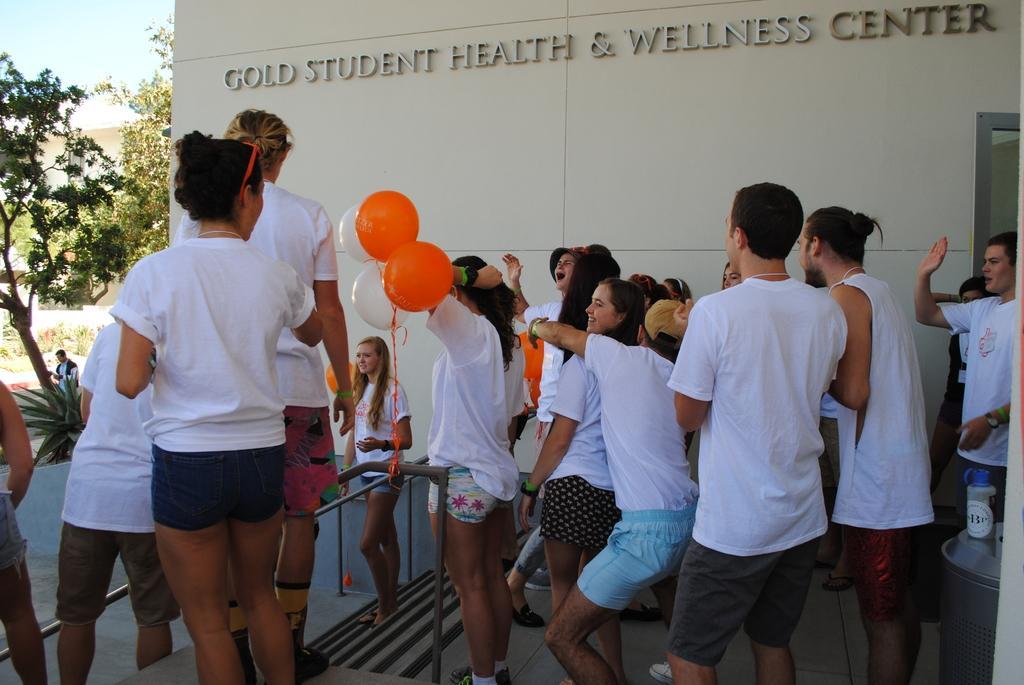Describe this image in one or two sentences. In this picture we can see some objects on the right side. We can see a few people, stairs, railings, balloons and the text on a wall. There are plants, trees, other objects and architecture. We can see the sky. 